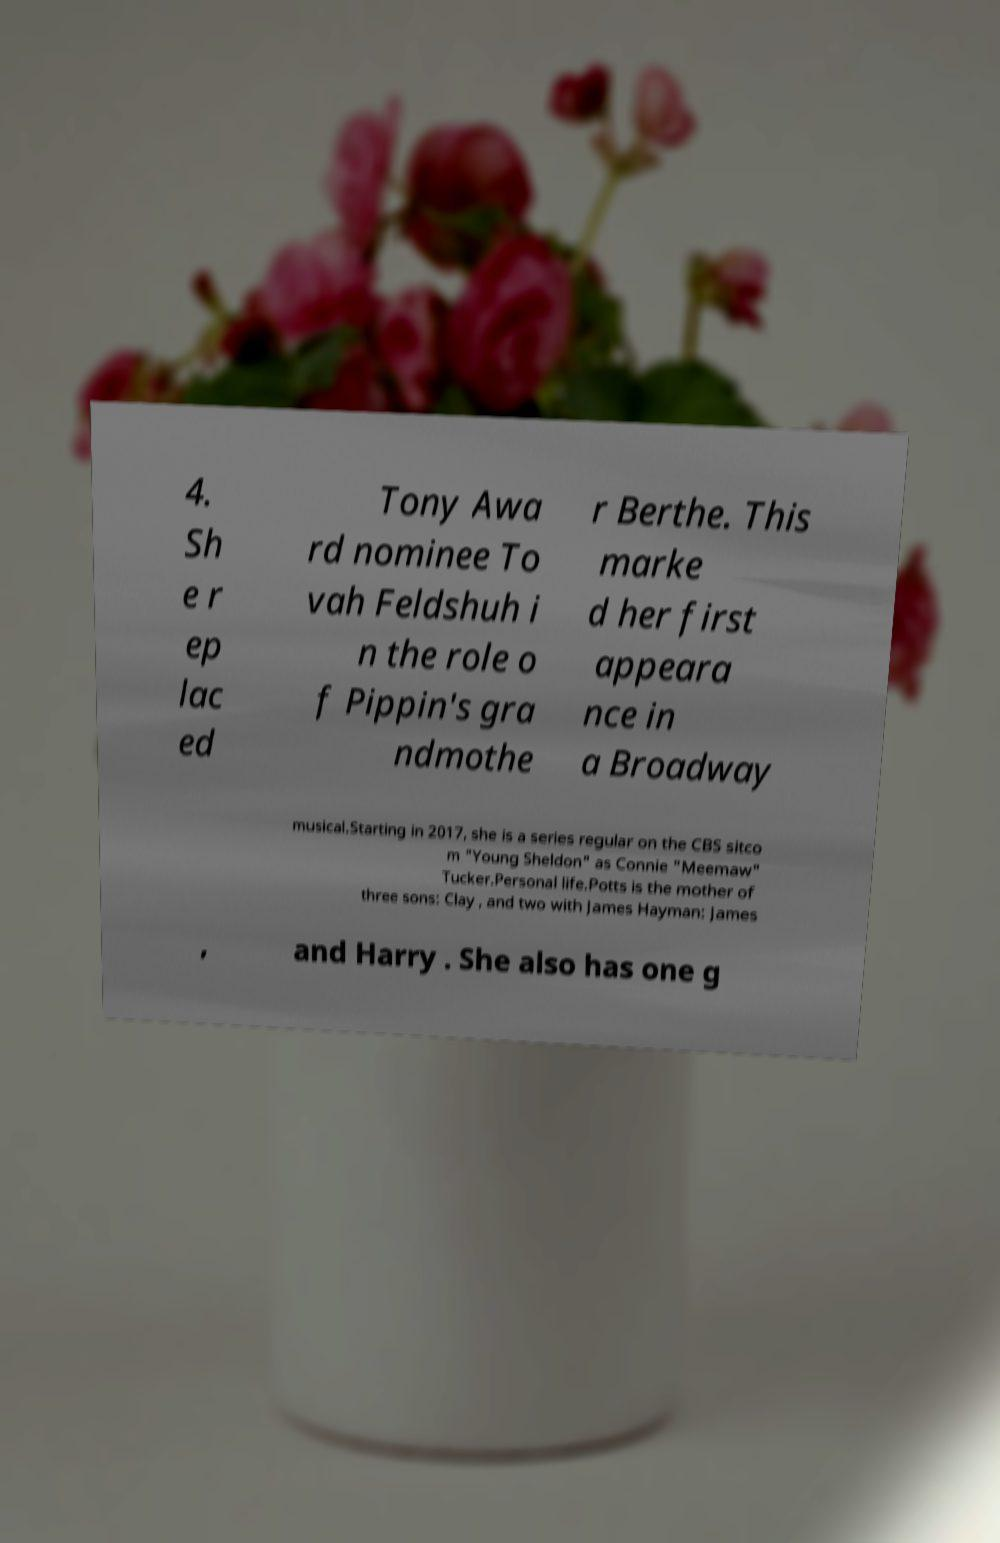Please read and relay the text visible in this image. What does it say? 4. Sh e r ep lac ed Tony Awa rd nominee To vah Feldshuh i n the role o f Pippin's gra ndmothe r Berthe. This marke d her first appeara nce in a Broadway musical.Starting in 2017, she is a series regular on the CBS sitco m "Young Sheldon" as Connie "Meemaw" Tucker.Personal life.Potts is the mother of three sons: Clay , and two with James Hayman: James , and Harry . She also has one g 